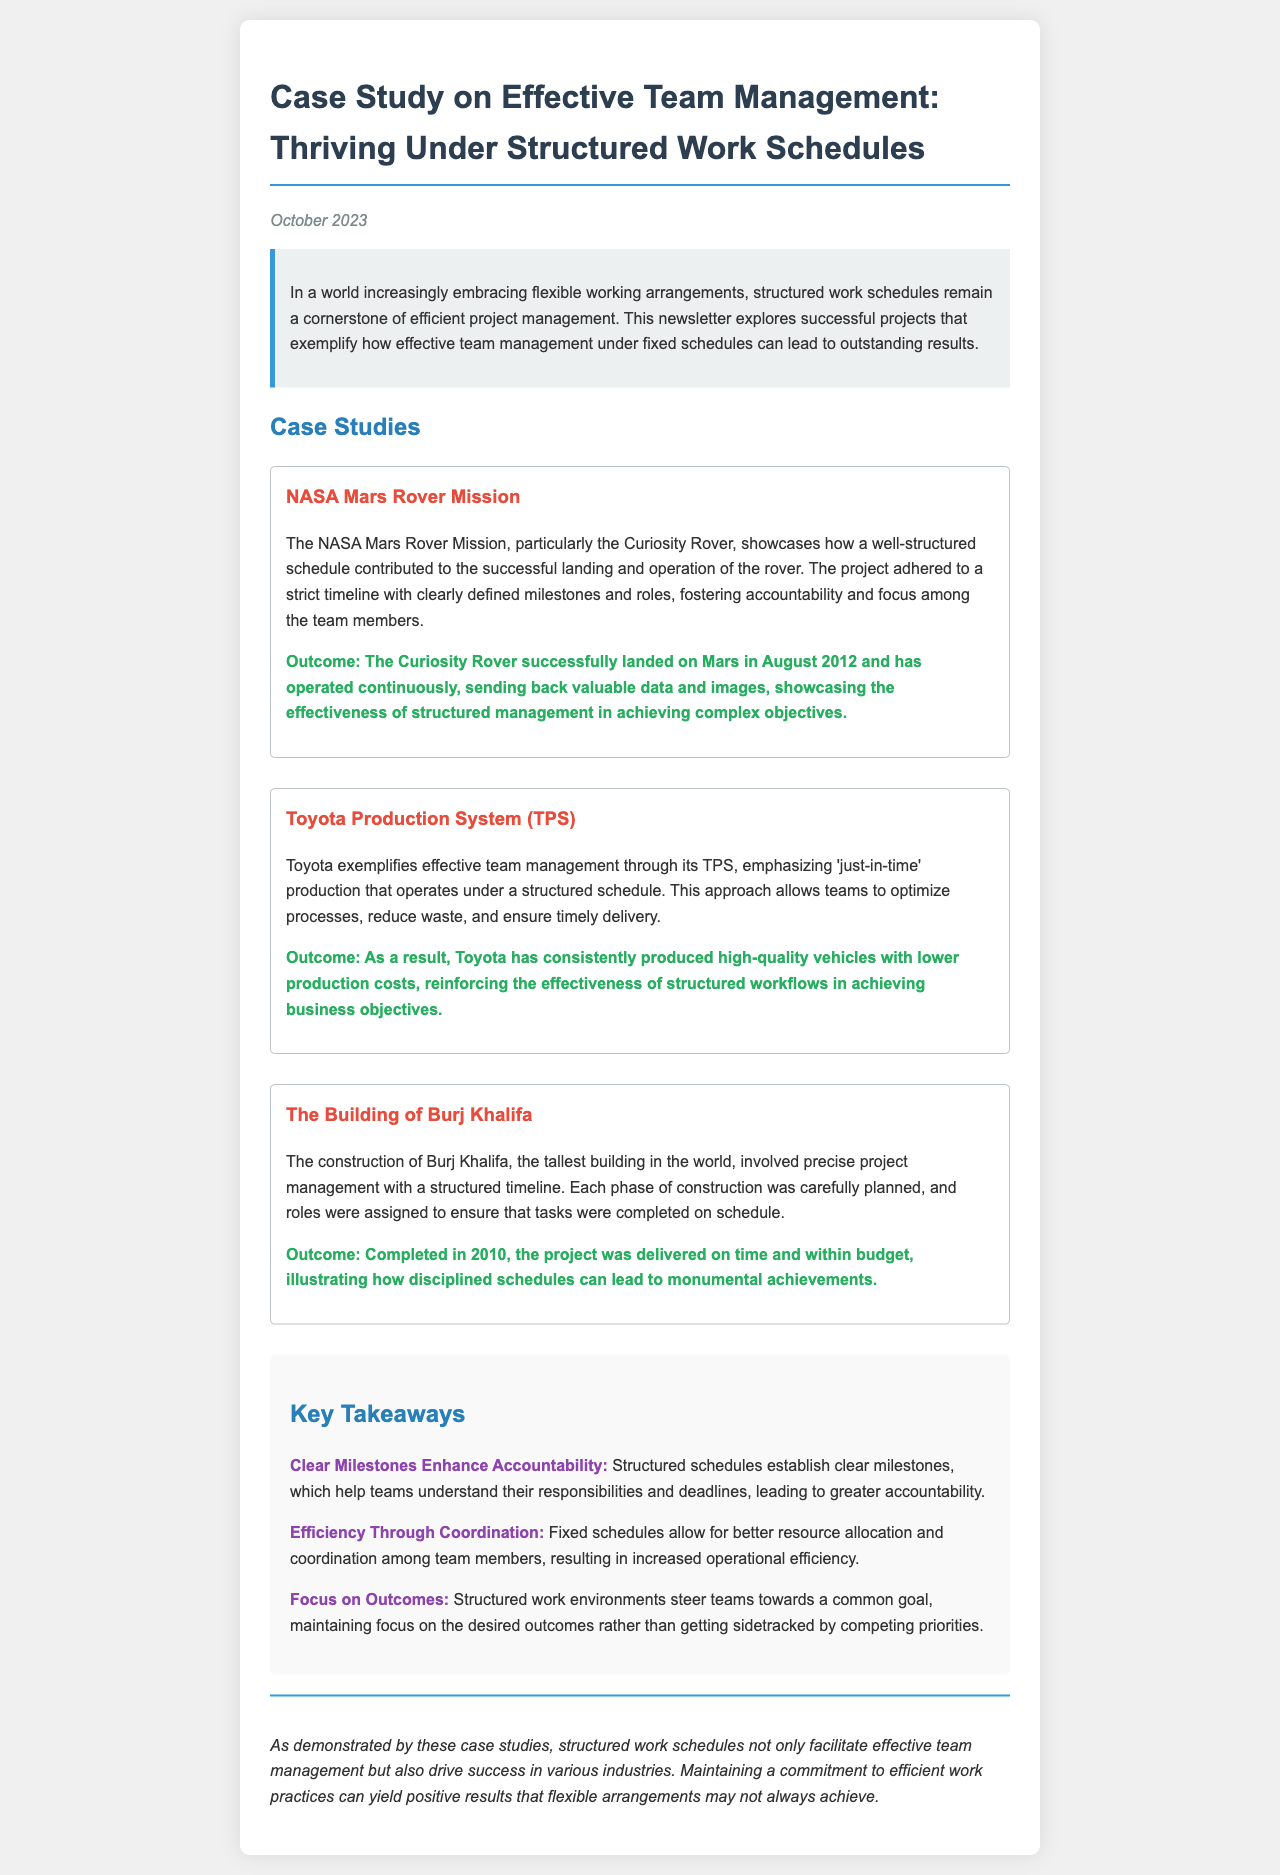What is the title of the newsletter? The title of the newsletter is found at the beginning of the document, which is "Case Study on Effective Team Management: Thriving Under Structured Work Schedules."
Answer: Case Study on Effective Team Management: Thriving Under Structured Work Schedules When was the newsletter published? The publication date is mentioned right below the title in the document.
Answer: October 2023 What project is highlighted as the first case study? The first case study mentioned in the newsletter is listed under the "Case Studies" section.
Answer: NASA Mars Rover Mission What outcome is associated with the NASA Mars Rover Mission? The outcome of the NASA Mars Rover Mission is provided in the case study text.
Answer: The Curiosity Rover successfully landed on Mars in August 2012 What does TPS stand for in the Toyota case study? The abbreviation TPS is mentioned in the description of the Toyota case study.
Answer: Toyota Production System What is the main theme of the key takeaways section? The main theme can be deduced from the summarizing points outlined in the takeaways.
Answer: Structured schedules enhance accountability How many case studies are presented in the newsletter? The number of case studies can be counted from the "Case Studies" section.
Answer: Three In which year was Burj Khalifa completed? The completion year of Burj Khalifa is noted in the construction case study.
Answer: 2010 What is emphasized as a benefit of structured schedules according to the conclusion? The conclusion highlights the overall benefits of maintaining structured schedules in team management.
Answer: Drive success in various industries 